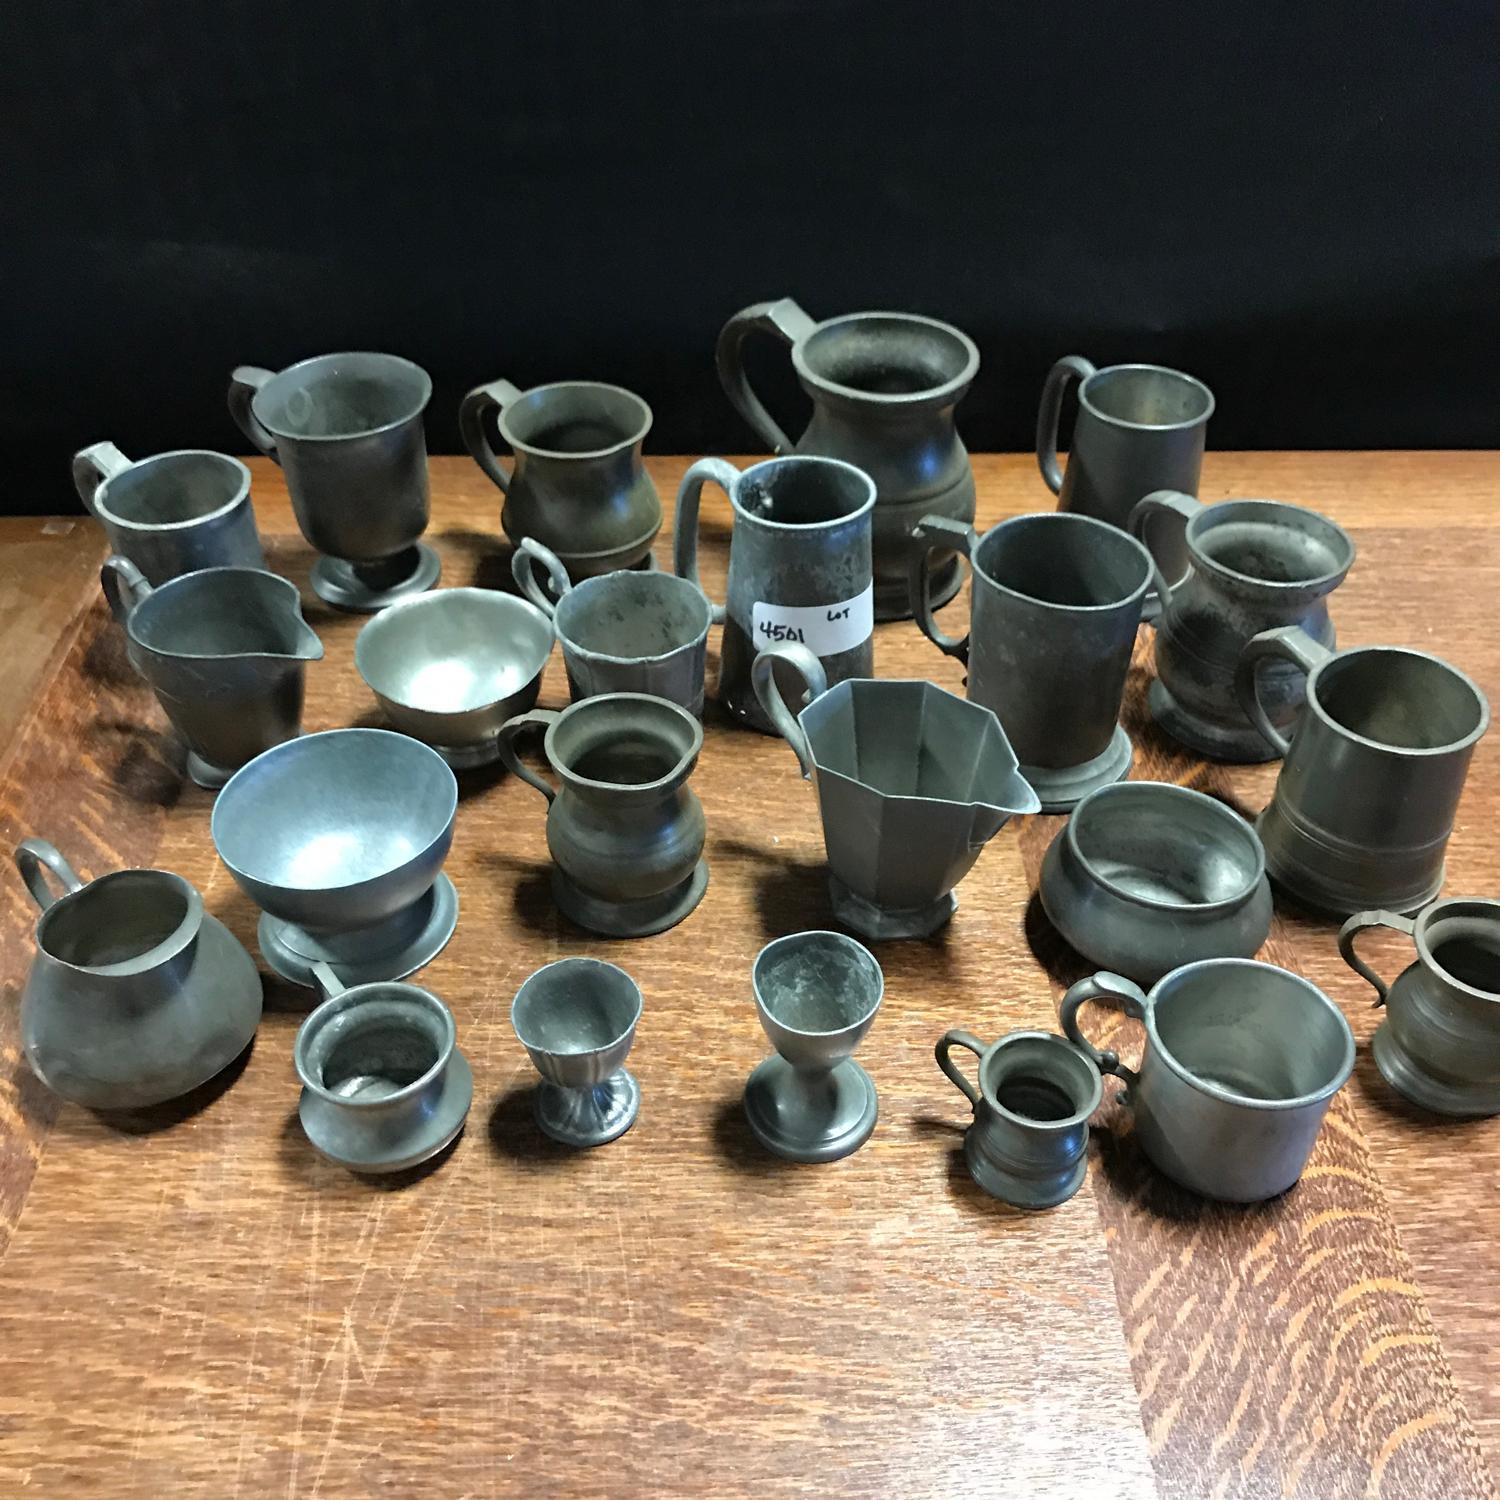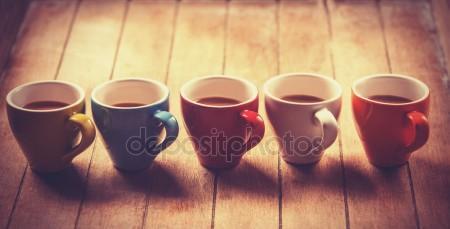The first image is the image on the left, the second image is the image on the right. Assess this claim about the two images: "The left and right image contains a total of no more than ten cups.". Correct or not? Answer yes or no. No. 